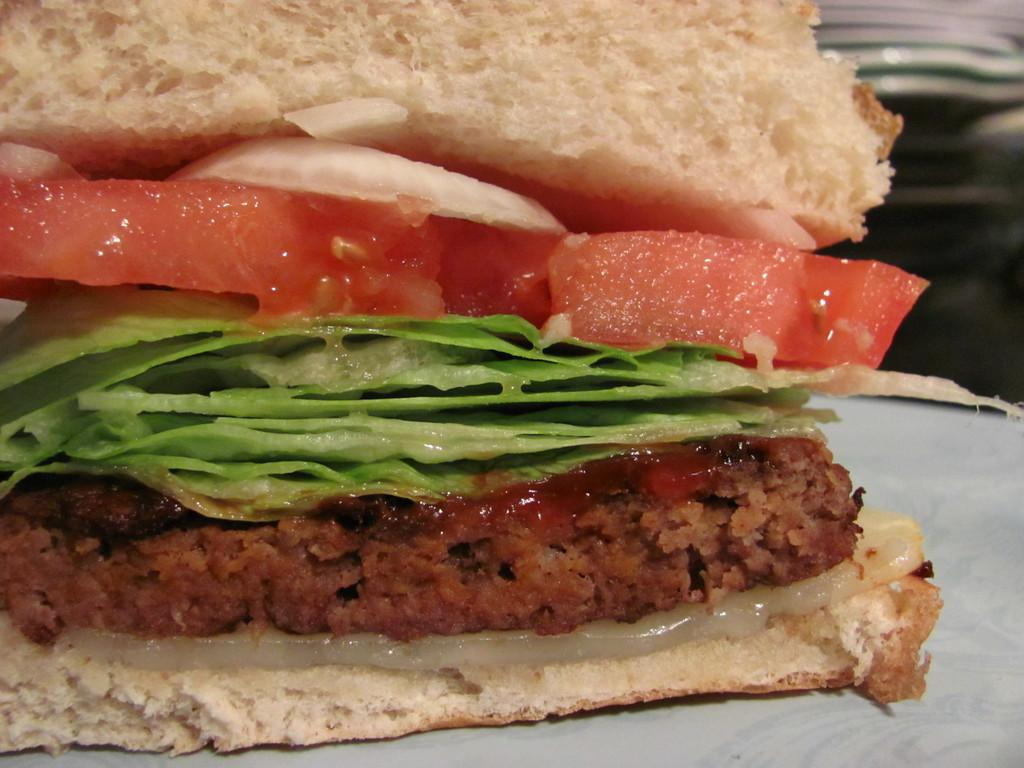What is the main subject of the image? There is a food item in the image. Can you describe the surface on which the food item is placed? The food item is on a white color surface. Is there a woman or a fireman in the image? There is no woman or fireman present in the image; it only features a food item on a white color surface. 